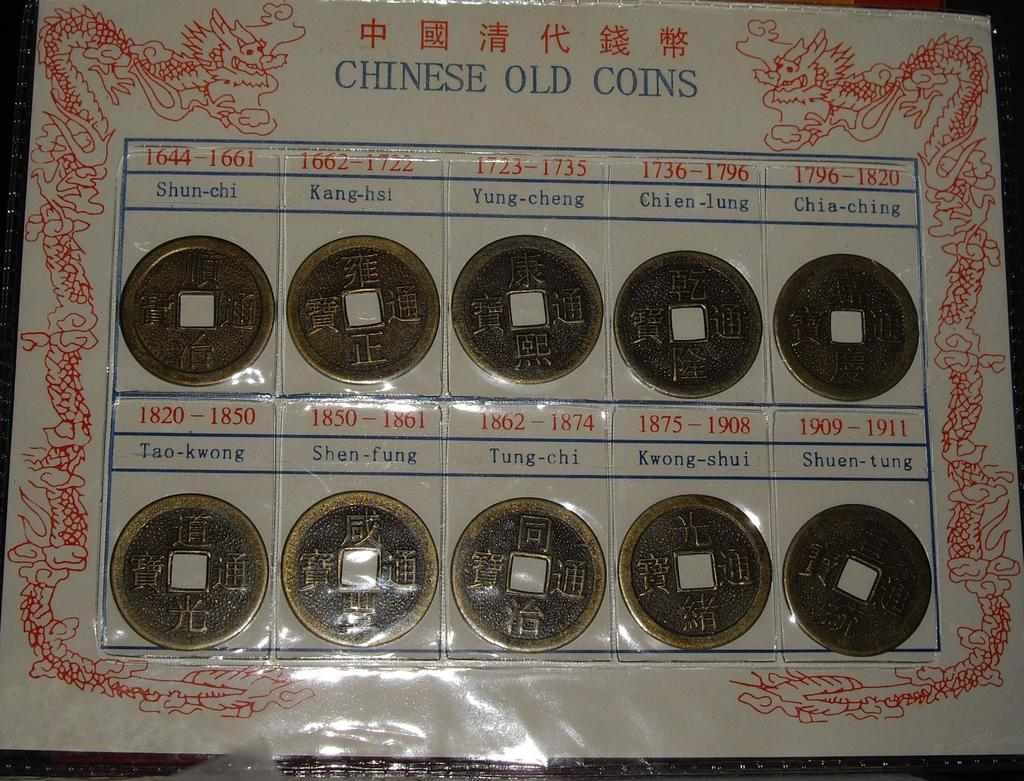Provide a one-sentence caption for the provided image. A collection of old Chinese coins in a plastic display with each coin year and location labeled. 